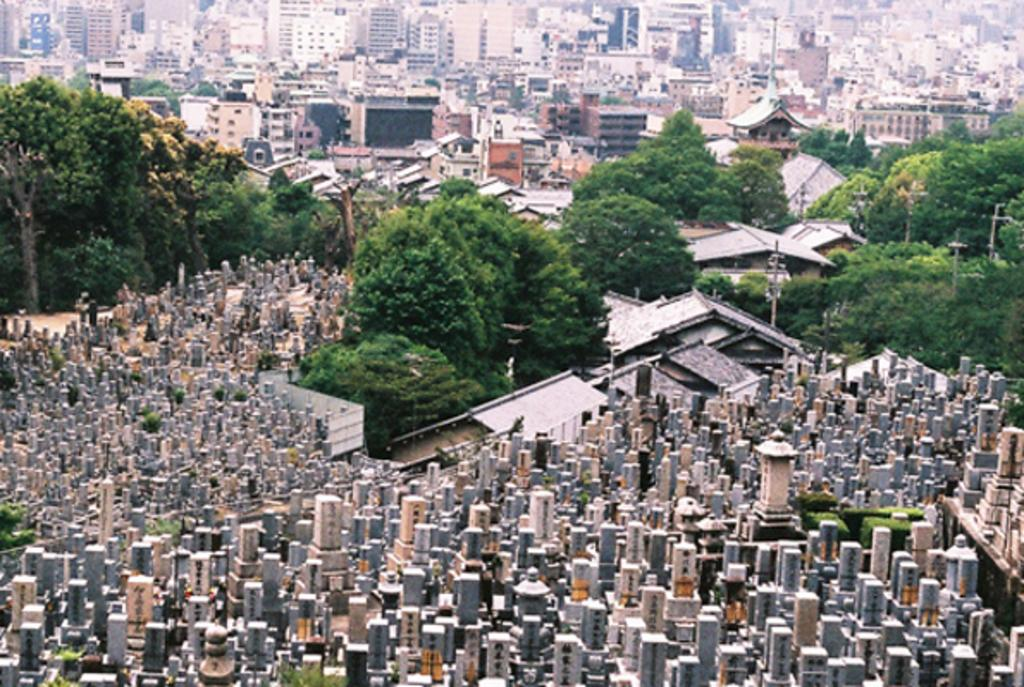What is the main subject of the image? The main subject of the image is many buildings. Can you describe the appearance of the buildings? The buildings are in multiple colors. What can be seen in the background of the image? There are trees in the background of the image. What is the color of the trees? The trees are green in color. What type of shirt is hanging from the string in the image? There is no shirt or string present in the image. What operation is being performed on the buildings in the image? There is no operation being performed on the buildings in the image; they are simply standing as they are. 